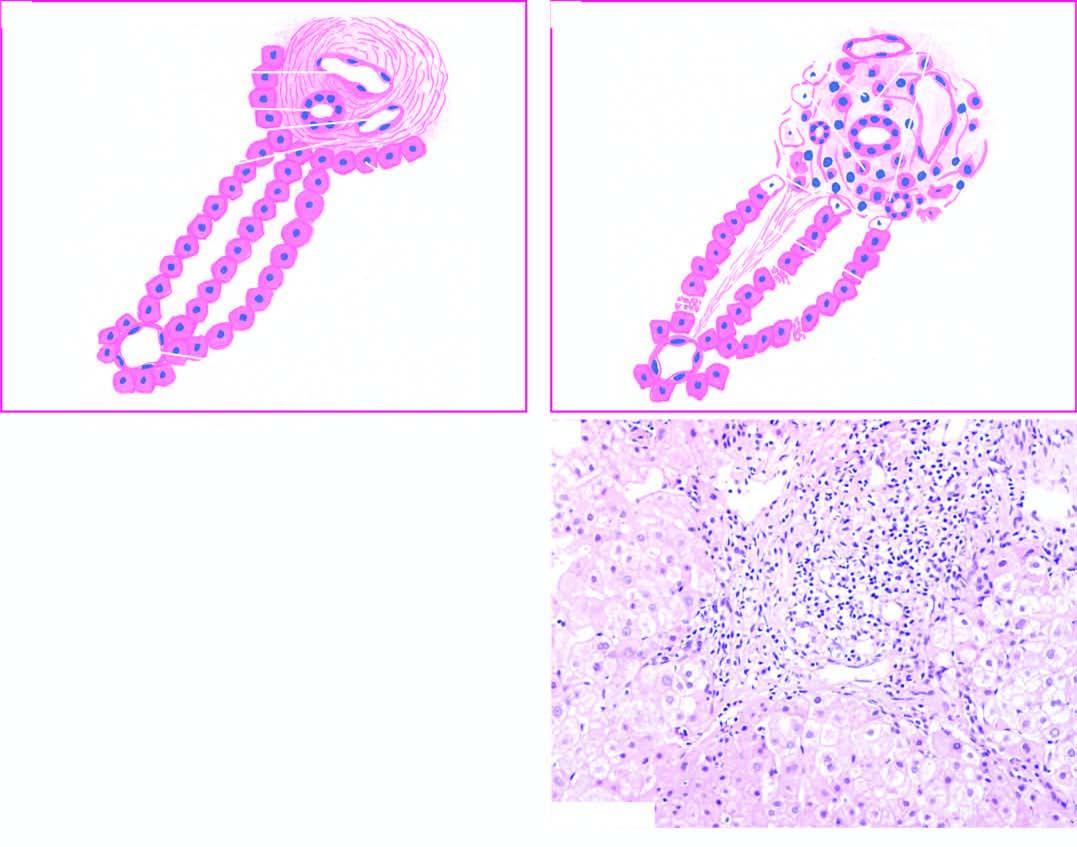s diagrammatic representation of pathologic changes in chronic hepatitis contrasted with normal morphology?
Answer the question using a single word or phrase. Yes 